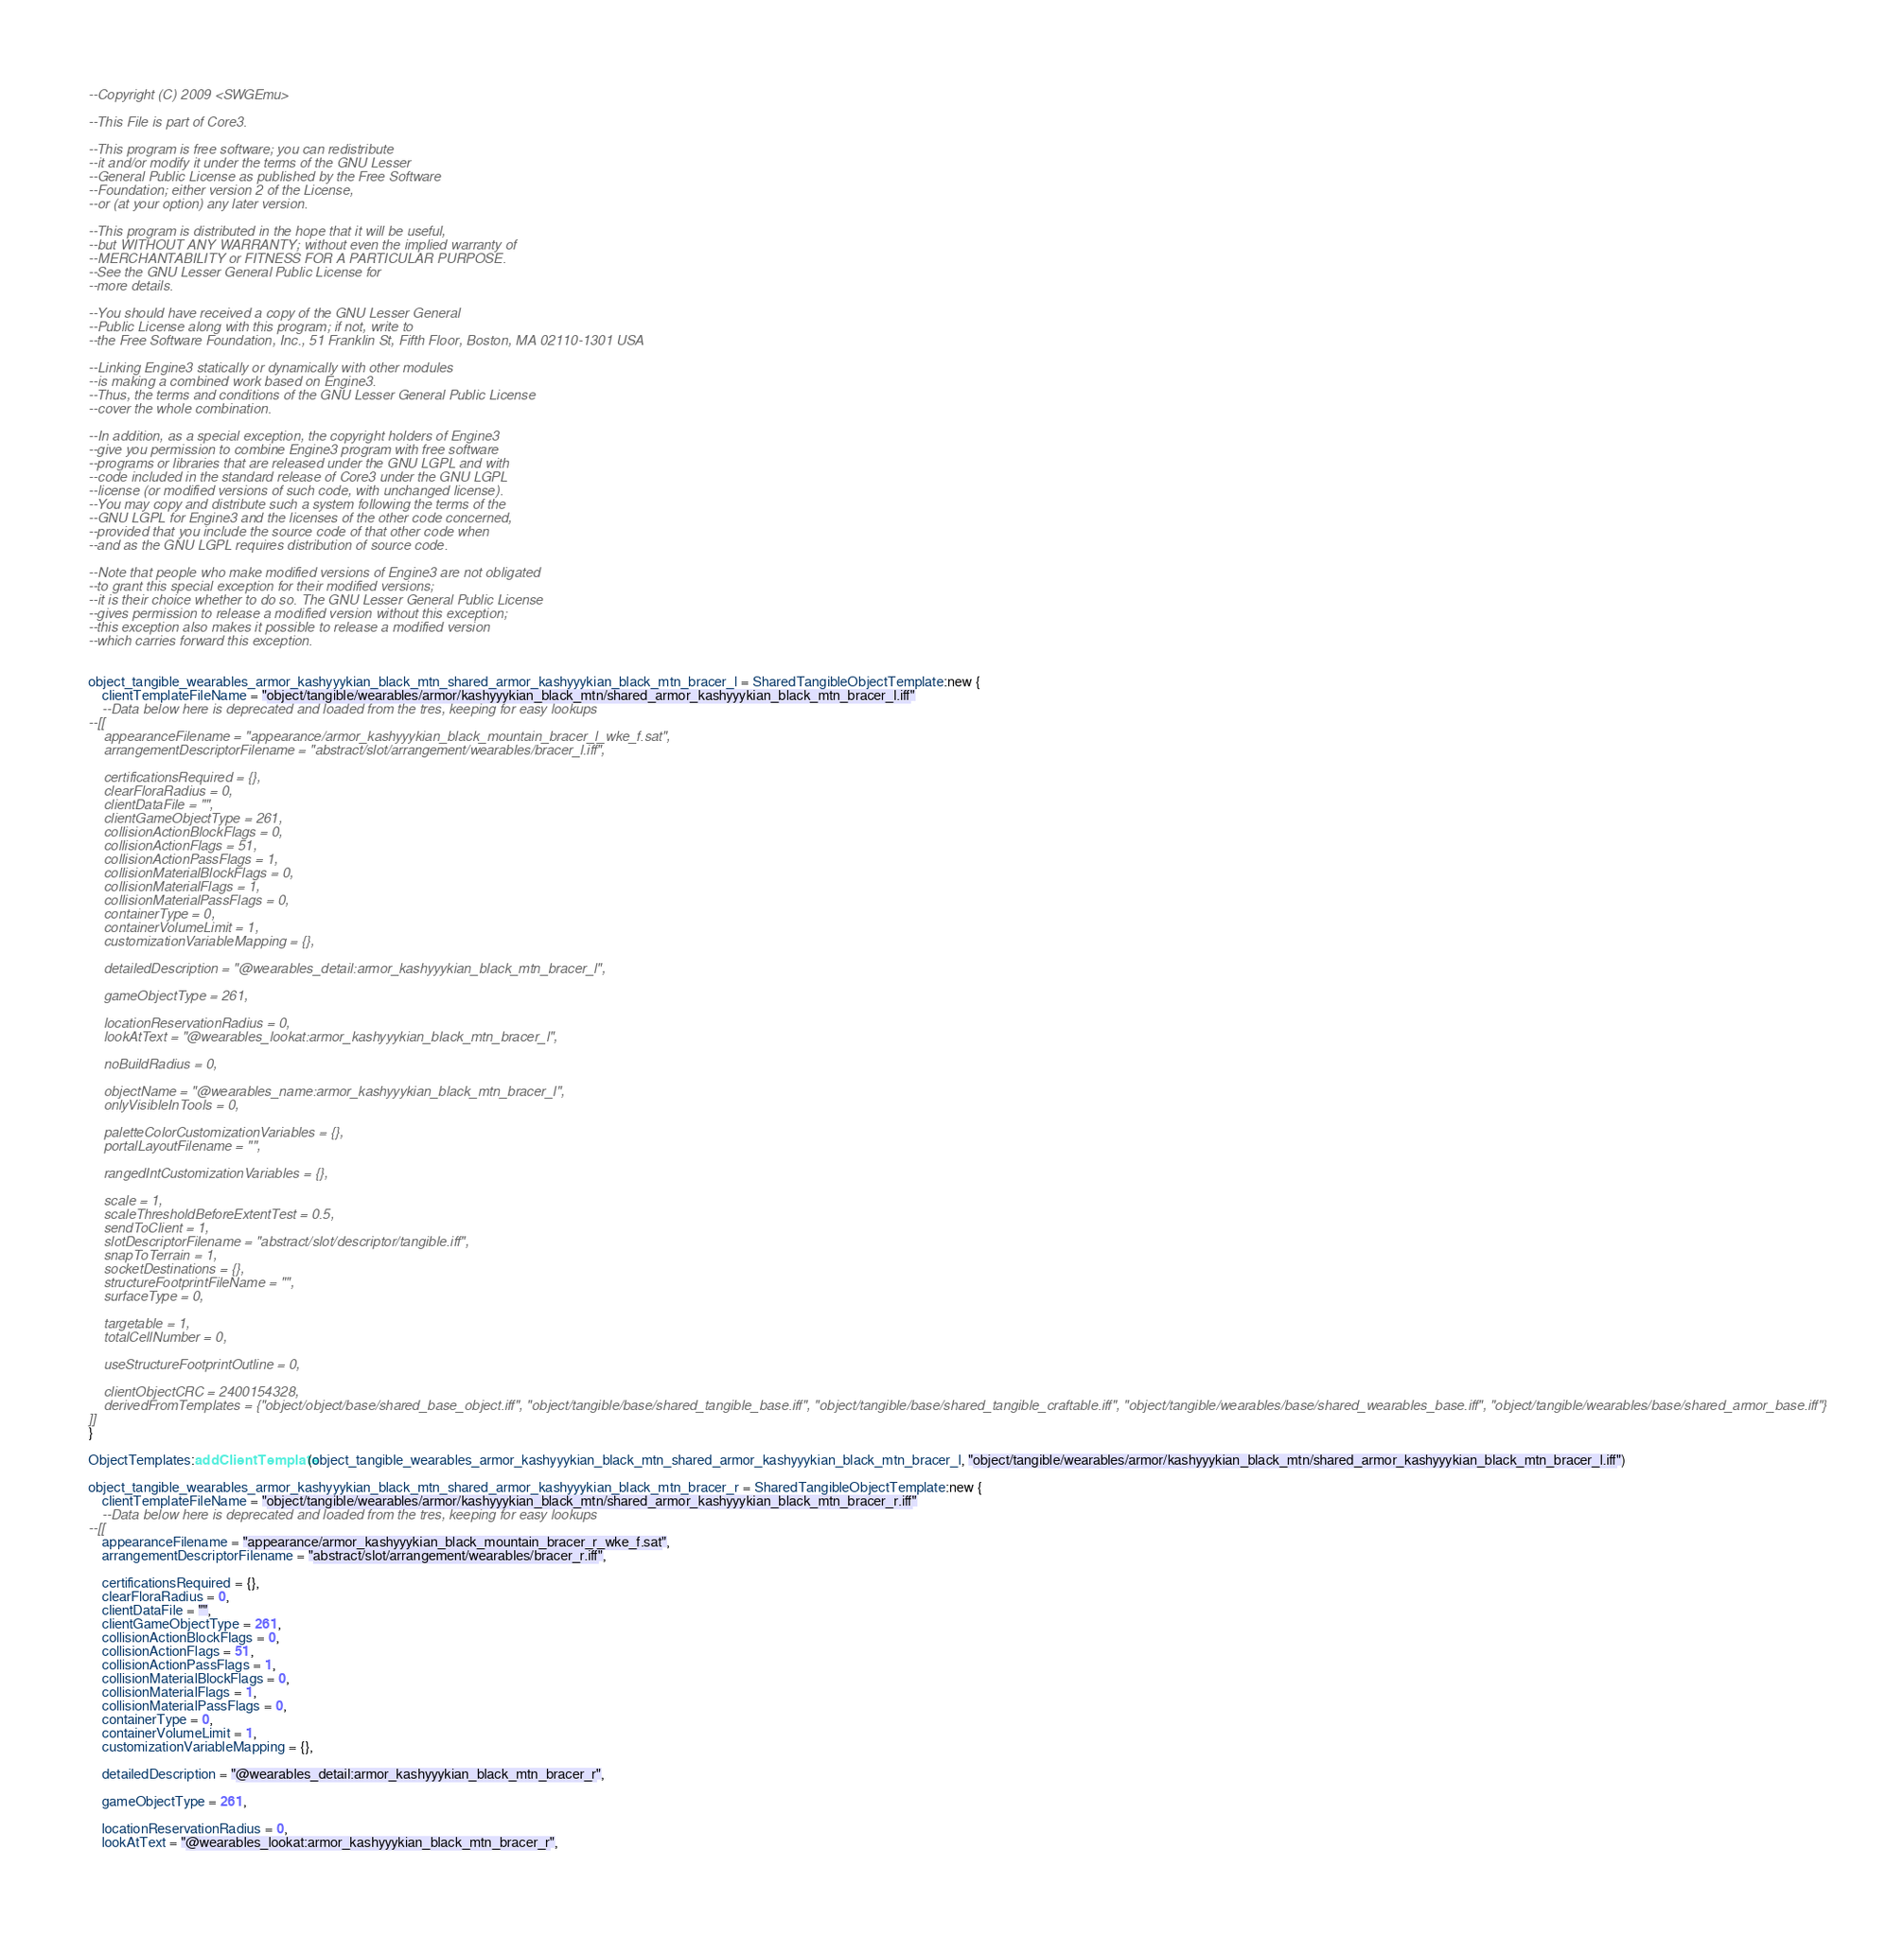Convert code to text. <code><loc_0><loc_0><loc_500><loc_500><_Lua_>--Copyright (C) 2009 <SWGEmu>

--This File is part of Core3.

--This program is free software; you can redistribute
--it and/or modify it under the terms of the GNU Lesser
--General Public License as published by the Free Software
--Foundation; either version 2 of the License,
--or (at your option) any later version.

--This program is distributed in the hope that it will be useful,
--but WITHOUT ANY WARRANTY; without even the implied warranty of
--MERCHANTABILITY or FITNESS FOR A PARTICULAR PURPOSE.
--See the GNU Lesser General Public License for
--more details.

--You should have received a copy of the GNU Lesser General
--Public License along with this program; if not, write to
--the Free Software Foundation, Inc., 51 Franklin St, Fifth Floor, Boston, MA 02110-1301 USA

--Linking Engine3 statically or dynamically with other modules
--is making a combined work based on Engine3.
--Thus, the terms and conditions of the GNU Lesser General Public License
--cover the whole combination.

--In addition, as a special exception, the copyright holders of Engine3
--give you permission to combine Engine3 program with free software
--programs or libraries that are released under the GNU LGPL and with
--code included in the standard release of Core3 under the GNU LGPL
--license (or modified versions of such code, with unchanged license).
--You may copy and distribute such a system following the terms of the
--GNU LGPL for Engine3 and the licenses of the other code concerned,
--provided that you include the source code of that other code when
--and as the GNU LGPL requires distribution of source code.

--Note that people who make modified versions of Engine3 are not obligated
--to grant this special exception for their modified versions;
--it is their choice whether to do so. The GNU Lesser General Public License
--gives permission to release a modified version without this exception;
--this exception also makes it possible to release a modified version
--which carries forward this exception.


object_tangible_wearables_armor_kashyyykian_black_mtn_shared_armor_kashyyykian_black_mtn_bracer_l = SharedTangibleObjectTemplate:new {
	clientTemplateFileName = "object/tangible/wearables/armor/kashyyykian_black_mtn/shared_armor_kashyyykian_black_mtn_bracer_l.iff"
	--Data below here is deprecated and loaded from the tres, keeping for easy lookups
--[[
	appearanceFilename = "appearance/armor_kashyyykian_black_mountain_bracer_l_wke_f.sat",
	arrangementDescriptorFilename = "abstract/slot/arrangement/wearables/bracer_l.iff",

	certificationsRequired = {},
	clearFloraRadius = 0,
	clientDataFile = "",
	clientGameObjectType = 261,
	collisionActionBlockFlags = 0,
	collisionActionFlags = 51,
	collisionActionPassFlags = 1,
	collisionMaterialBlockFlags = 0,
	collisionMaterialFlags = 1,
	collisionMaterialPassFlags = 0,
	containerType = 0,
	containerVolumeLimit = 1,
	customizationVariableMapping = {},

	detailedDescription = "@wearables_detail:armor_kashyyykian_black_mtn_bracer_l",

	gameObjectType = 261,

	locationReservationRadius = 0,
	lookAtText = "@wearables_lookat:armor_kashyyykian_black_mtn_bracer_l",

	noBuildRadius = 0,

	objectName = "@wearables_name:armor_kashyyykian_black_mtn_bracer_l",
	onlyVisibleInTools = 0,

	paletteColorCustomizationVariables = {},
	portalLayoutFilename = "",

	rangedIntCustomizationVariables = {},

	scale = 1,
	scaleThresholdBeforeExtentTest = 0.5,
	sendToClient = 1,
	slotDescriptorFilename = "abstract/slot/descriptor/tangible.iff",
	snapToTerrain = 1,
	socketDestinations = {},
	structureFootprintFileName = "",
	surfaceType = 0,

	targetable = 1,
	totalCellNumber = 0,

	useStructureFootprintOutline = 0,

	clientObjectCRC = 2400154328,
	derivedFromTemplates = {"object/object/base/shared_base_object.iff", "object/tangible/base/shared_tangible_base.iff", "object/tangible/base/shared_tangible_craftable.iff", "object/tangible/wearables/base/shared_wearables_base.iff", "object/tangible/wearables/base/shared_armor_base.iff"}
]]
}

ObjectTemplates:addClientTemplate(object_tangible_wearables_armor_kashyyykian_black_mtn_shared_armor_kashyyykian_black_mtn_bracer_l, "object/tangible/wearables/armor/kashyyykian_black_mtn/shared_armor_kashyyykian_black_mtn_bracer_l.iff")

object_tangible_wearables_armor_kashyyykian_black_mtn_shared_armor_kashyyykian_black_mtn_bracer_r = SharedTangibleObjectTemplate:new {
	clientTemplateFileName = "object/tangible/wearables/armor/kashyyykian_black_mtn/shared_armor_kashyyykian_black_mtn_bracer_r.iff"
	--Data below here is deprecated and loaded from the tres, keeping for easy lookups
--[[
	appearanceFilename = "appearance/armor_kashyyykian_black_mountain_bracer_r_wke_f.sat",
	arrangementDescriptorFilename = "abstract/slot/arrangement/wearables/bracer_r.iff",

	certificationsRequired = {},
	clearFloraRadius = 0,
	clientDataFile = "",
	clientGameObjectType = 261,
	collisionActionBlockFlags = 0,
	collisionActionFlags = 51,
	collisionActionPassFlags = 1,
	collisionMaterialBlockFlags = 0,
	collisionMaterialFlags = 1,
	collisionMaterialPassFlags = 0,
	containerType = 0,
	containerVolumeLimit = 1,
	customizationVariableMapping = {},

	detailedDescription = "@wearables_detail:armor_kashyyykian_black_mtn_bracer_r",

	gameObjectType = 261,

	locationReservationRadius = 0,
	lookAtText = "@wearables_lookat:armor_kashyyykian_black_mtn_bracer_r",
</code> 